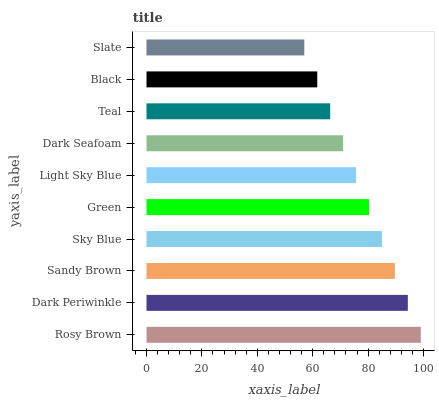Is Slate the minimum?
Answer yes or no. Yes. Is Rosy Brown the maximum?
Answer yes or no. Yes. Is Dark Periwinkle the minimum?
Answer yes or no. No. Is Dark Periwinkle the maximum?
Answer yes or no. No. Is Rosy Brown greater than Dark Periwinkle?
Answer yes or no. Yes. Is Dark Periwinkle less than Rosy Brown?
Answer yes or no. Yes. Is Dark Periwinkle greater than Rosy Brown?
Answer yes or no. No. Is Rosy Brown less than Dark Periwinkle?
Answer yes or no. No. Is Green the high median?
Answer yes or no. Yes. Is Light Sky Blue the low median?
Answer yes or no. Yes. Is Teal the high median?
Answer yes or no. No. Is Black the low median?
Answer yes or no. No. 